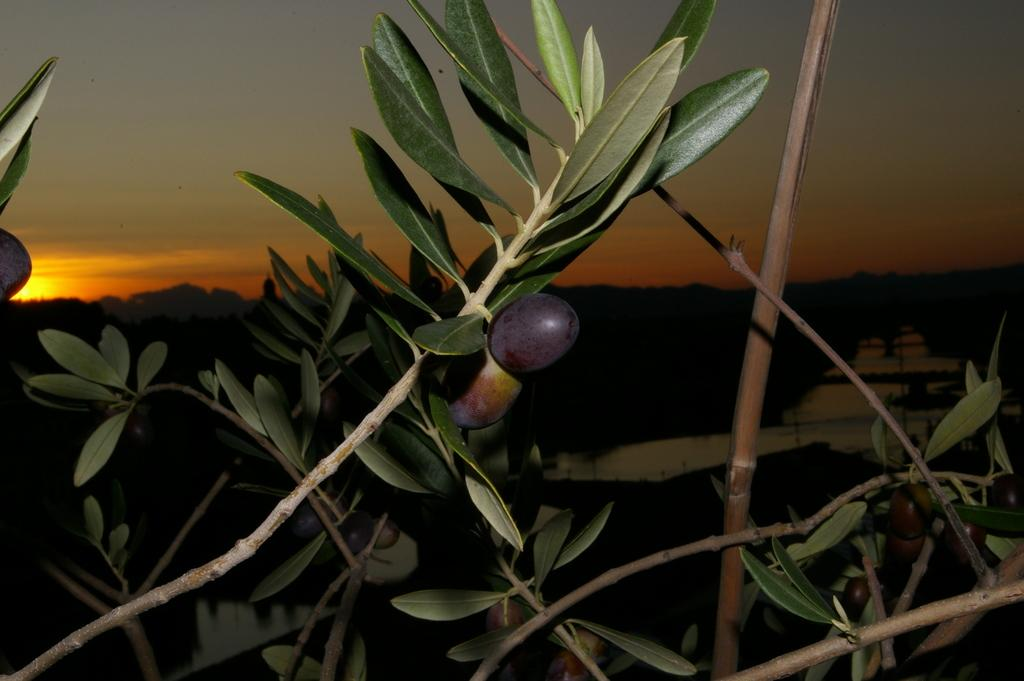What is the main subject in the center of the image? There are branches with leaves and fruits in the center of the image. What can be seen in the background of the image? The sky is visible in the background of the image. How would you describe the color of the sky in the image? The bottom of the sky has a dark background. How many people are trying to get the attention of the crook in the image? There is no crook or people present in the image; it features branches with leaves and fruits against a sky background. 